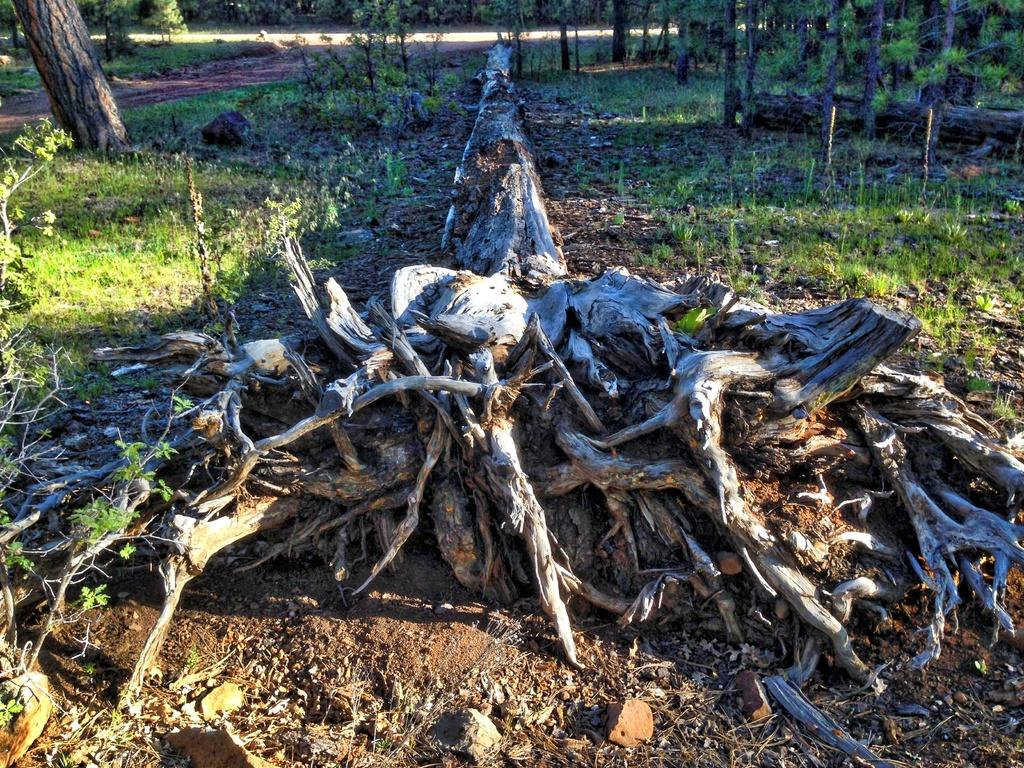What type of vegetation can be seen in the foreground of the image? There are roots of a tree in the image. What type of vegetation can be seen in the background of the image? There is grass and plants in the background of the image. What type of maid can be seen cleaning the rat in the image? There is no maid or rat present in the image; it only features the roots of a tree and vegetation in the background. 